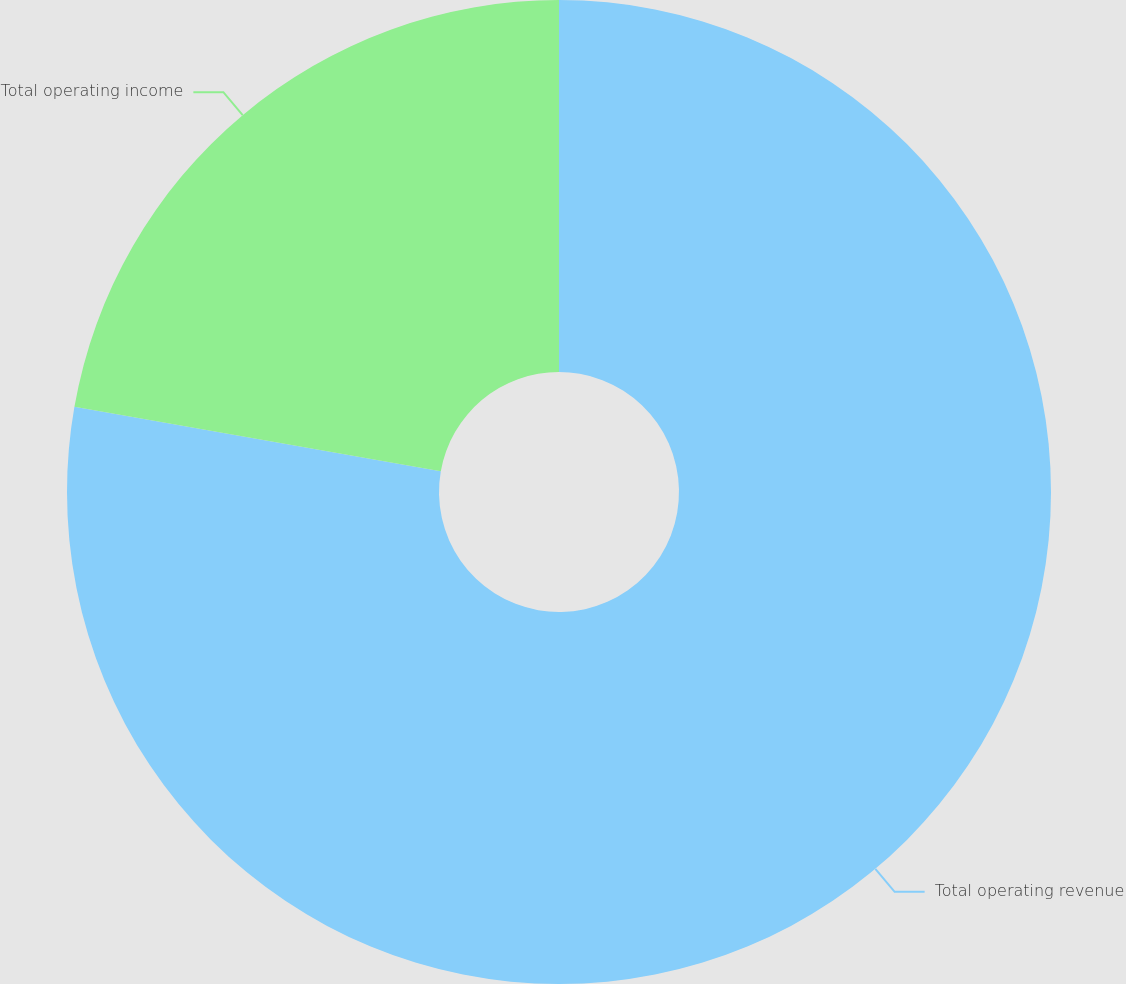Convert chart. <chart><loc_0><loc_0><loc_500><loc_500><pie_chart><fcel>Total operating revenue<fcel>Total operating income<nl><fcel>77.77%<fcel>22.23%<nl></chart> 